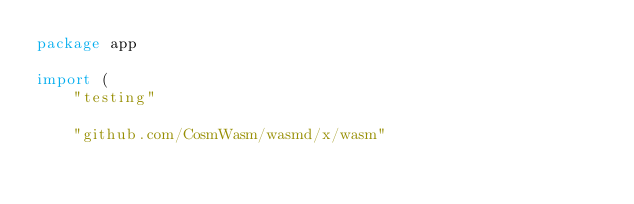Convert code to text. <code><loc_0><loc_0><loc_500><loc_500><_Go_>package app

import (
	"testing"

	"github.com/CosmWasm/wasmd/x/wasm"</code> 